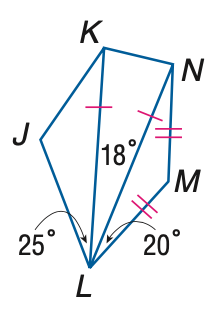Question: \triangle K L N and \triangle L M N are isosceles and m \angle J K N = 130. Find the measure of \angle L K N.
Choices:
A. 75
B. 78
C. 79
D. 81
Answer with the letter. Answer: D Question: \triangle K L N and \triangle L M N are isosceles and m \angle J K N = 130. Find the measure of \angle M.
Choices:
A. 110
B. 120
C. 130
D. 140
Answer with the letter. Answer: D Question: \triangle K L N and \triangle L M N are isosceles and m \angle J K N = 130. Find the measure of \angle L N M.
Choices:
A. 18
B. 20
C. 21
D. 25
Answer with the letter. Answer: B 